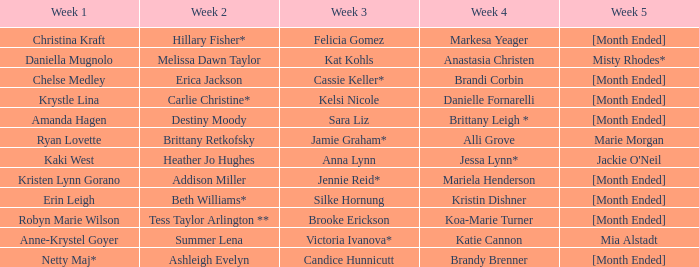What is the week 3 with addison miller in week 2? Jennie Reid*. 